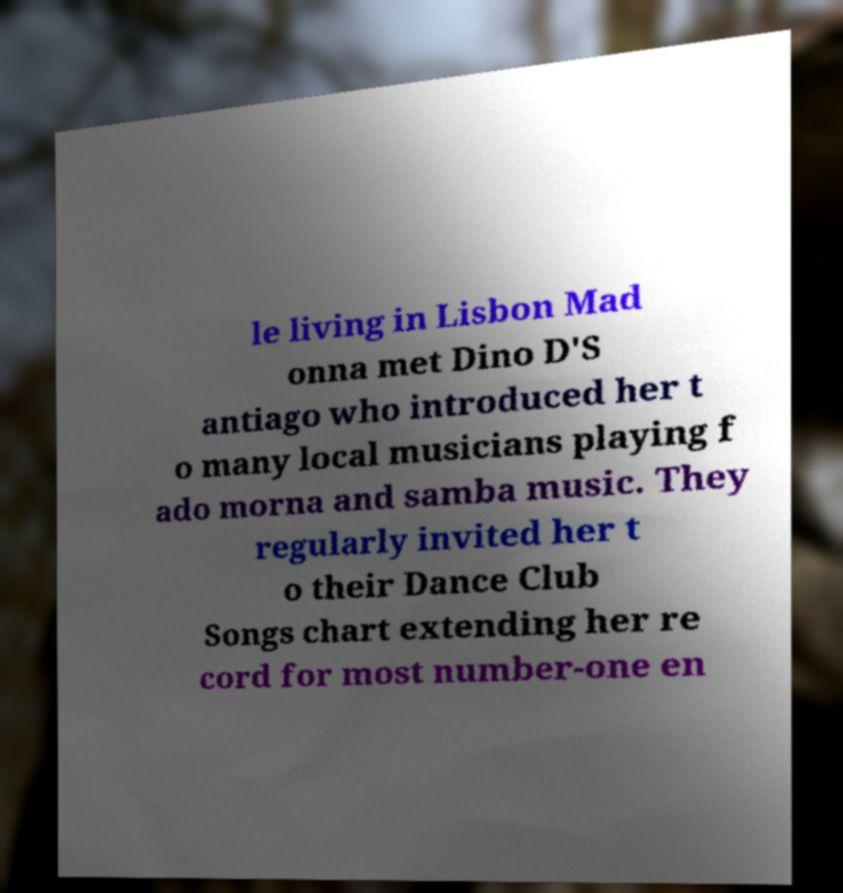Could you assist in decoding the text presented in this image and type it out clearly? le living in Lisbon Mad onna met Dino D'S antiago who introduced her t o many local musicians playing f ado morna and samba music. They regularly invited her t o their Dance Club Songs chart extending her re cord for most number-one en 